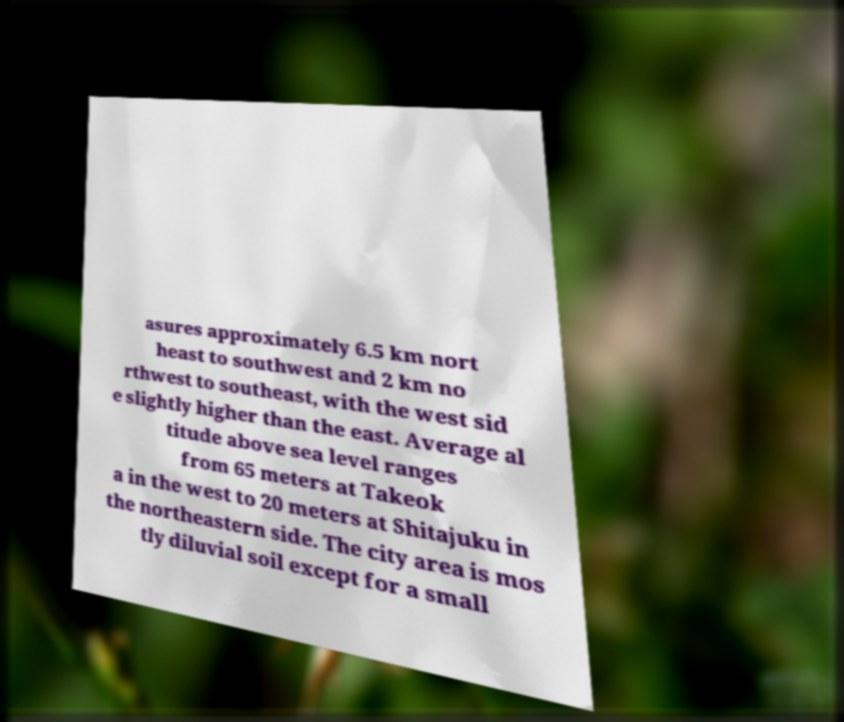What messages or text are displayed in this image? I need them in a readable, typed format. asures approximately 6.5 km nort heast to southwest and 2 km no rthwest to southeast, with the west sid e slightly higher than the east. Average al titude above sea level ranges from 65 meters at Takeok a in the west to 20 meters at Shitajuku in the northeastern side. The city area is mos tly diluvial soil except for a small 